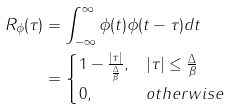<formula> <loc_0><loc_0><loc_500><loc_500>R _ { \phi } ( \tau ) & = \int _ { - \infty } ^ { \infty } \phi ( t ) \phi ( t - \tau ) d t \\ & = \begin{cases} 1 - \frac { | \tau | } { \frac { \Delta } { \beta } } , & | \tau | \leq \frac { \Delta } { \beta } \\ 0 , & o t h e r w i s e \end{cases}</formula> 